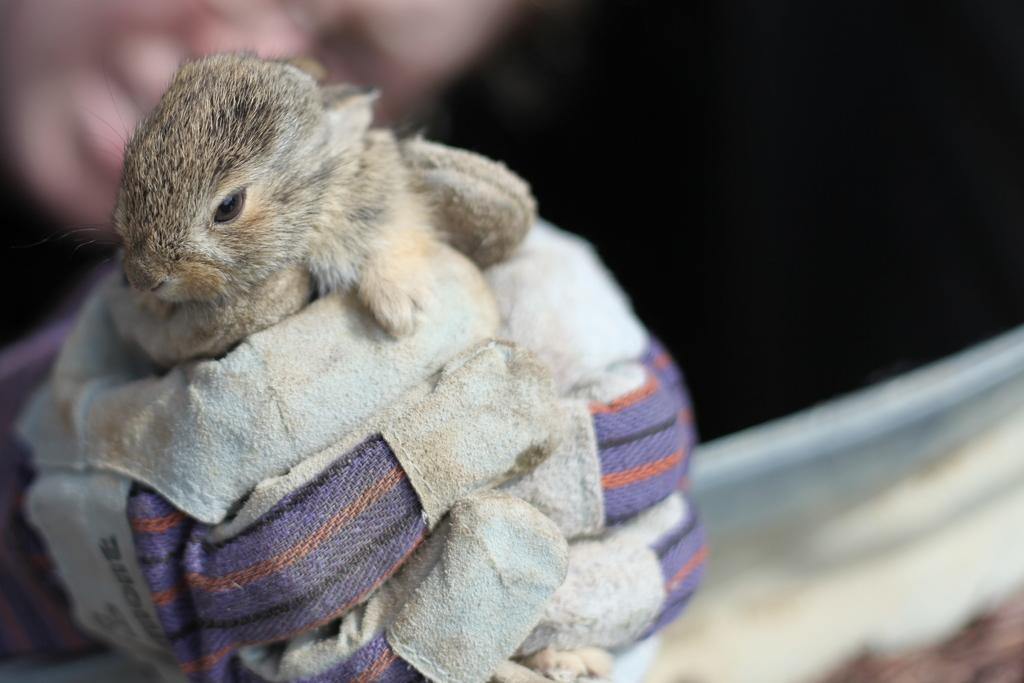What type of animal is in the image? There is a ground squirrel in the image. Where is the ground squirrel located in the image? The ground squirrel is on the left side of the image. What type of pie is the ground squirrel holding in the image? There is no pie present in the image; it features a ground squirrel on the left side. 